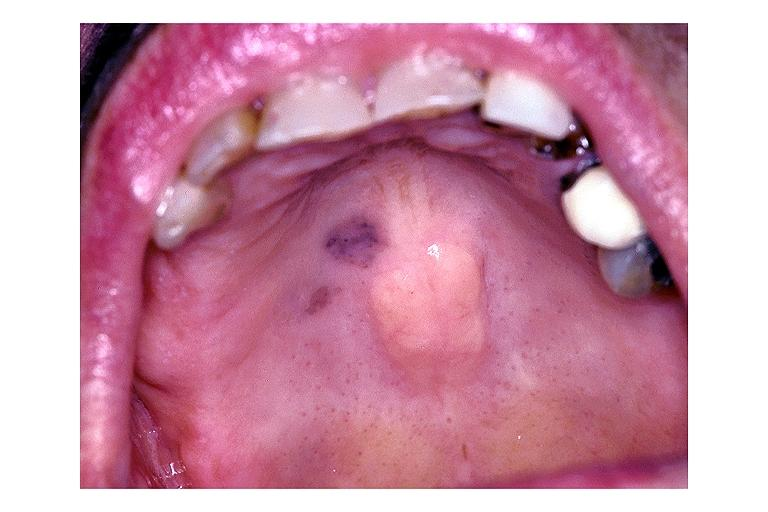s cut edge of mesentery present?
Answer the question using a single word or phrase. No 